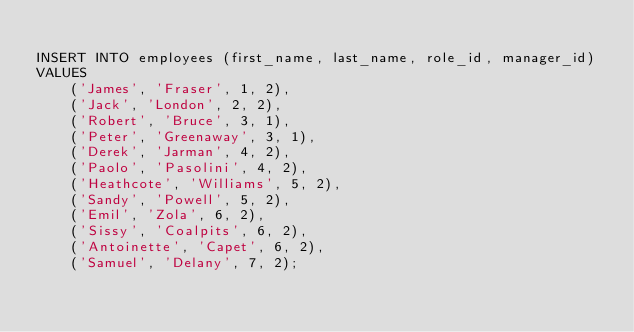Convert code to text. <code><loc_0><loc_0><loc_500><loc_500><_SQL_>
INSERT INTO employees (first_name, last_name, role_id, manager_id)
VALUES
    ('James', 'Fraser', 1, 2),
    ('Jack', 'London', 2, 2),
    ('Robert', 'Bruce', 3, 1),
    ('Peter', 'Greenaway', 3, 1),
    ('Derek', 'Jarman', 4, 2),
    ('Paolo', 'Pasolini', 4, 2),
    ('Heathcote', 'Williams', 5, 2),
    ('Sandy', 'Powell', 5, 2),
    ('Emil', 'Zola', 6, 2),
    ('Sissy', 'Coalpits', 6, 2),
    ('Antoinette', 'Capet', 6, 2),
    ('Samuel', 'Delany', 7, 2);
</code> 